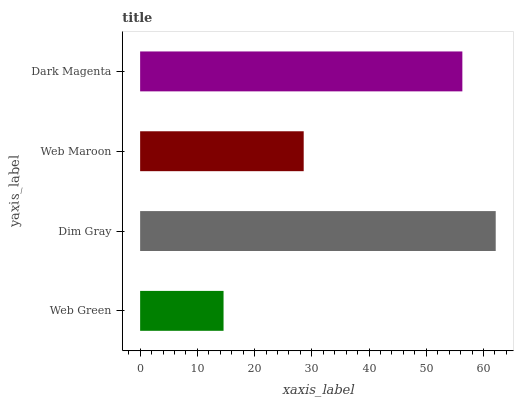Is Web Green the minimum?
Answer yes or no. Yes. Is Dim Gray the maximum?
Answer yes or no. Yes. Is Web Maroon the minimum?
Answer yes or no. No. Is Web Maroon the maximum?
Answer yes or no. No. Is Dim Gray greater than Web Maroon?
Answer yes or no. Yes. Is Web Maroon less than Dim Gray?
Answer yes or no. Yes. Is Web Maroon greater than Dim Gray?
Answer yes or no. No. Is Dim Gray less than Web Maroon?
Answer yes or no. No. Is Dark Magenta the high median?
Answer yes or no. Yes. Is Web Maroon the low median?
Answer yes or no. Yes. Is Web Green the high median?
Answer yes or no. No. Is Dim Gray the low median?
Answer yes or no. No. 